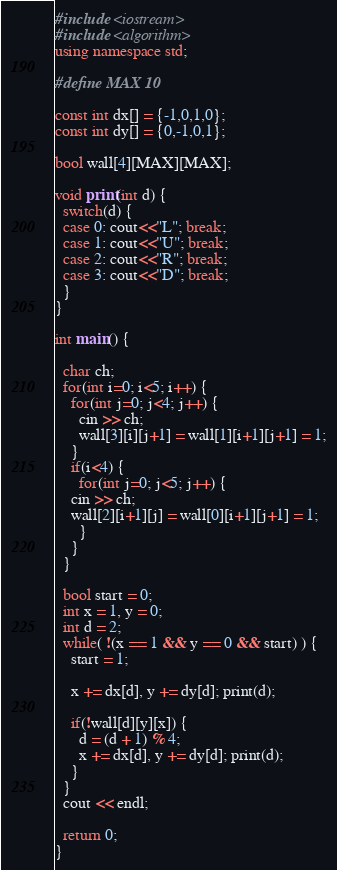Convert code to text. <code><loc_0><loc_0><loc_500><loc_500><_C++_>#include <iostream>
#include <algorithm>
using namespace std;

#define MAX 10

const int dx[] = {-1,0,1,0};
const int dy[] = {0,-1,0,1};

bool wall[4][MAX][MAX];

void print(int d) {
  switch(d) {
  case 0: cout<<"L"; break;
  case 1: cout<<"U"; break;
  case 2: cout<<"R"; break;
  case 3: cout<<"D"; break;
  }
}

int main() {
  
  char ch;
  for(int i=0; i<5; i++) {
    for(int j=0; j<4; j++) {
      cin >> ch;
      wall[3][i][j+1] = wall[1][i+1][j+1] = 1;
    }
    if(i<4) {
      for(int j=0; j<5; j++) {
	cin >> ch;
	wall[2][i+1][j] = wall[0][i+1][j+1] = 1;
      }
    }
  }
  
  bool start = 0;
  int x = 1, y = 0;
  int d = 2;
  while( !(x == 1 && y == 0 && start) ) {
    start = 1;
    
    x += dx[d], y += dy[d]; print(d);
    
    if(!wall[d][y][x]) {
      d = (d + 1) % 4;
      x += dx[d], y += dy[d]; print(d);
    }
  }
  cout << endl;
  
  return 0;
}</code> 